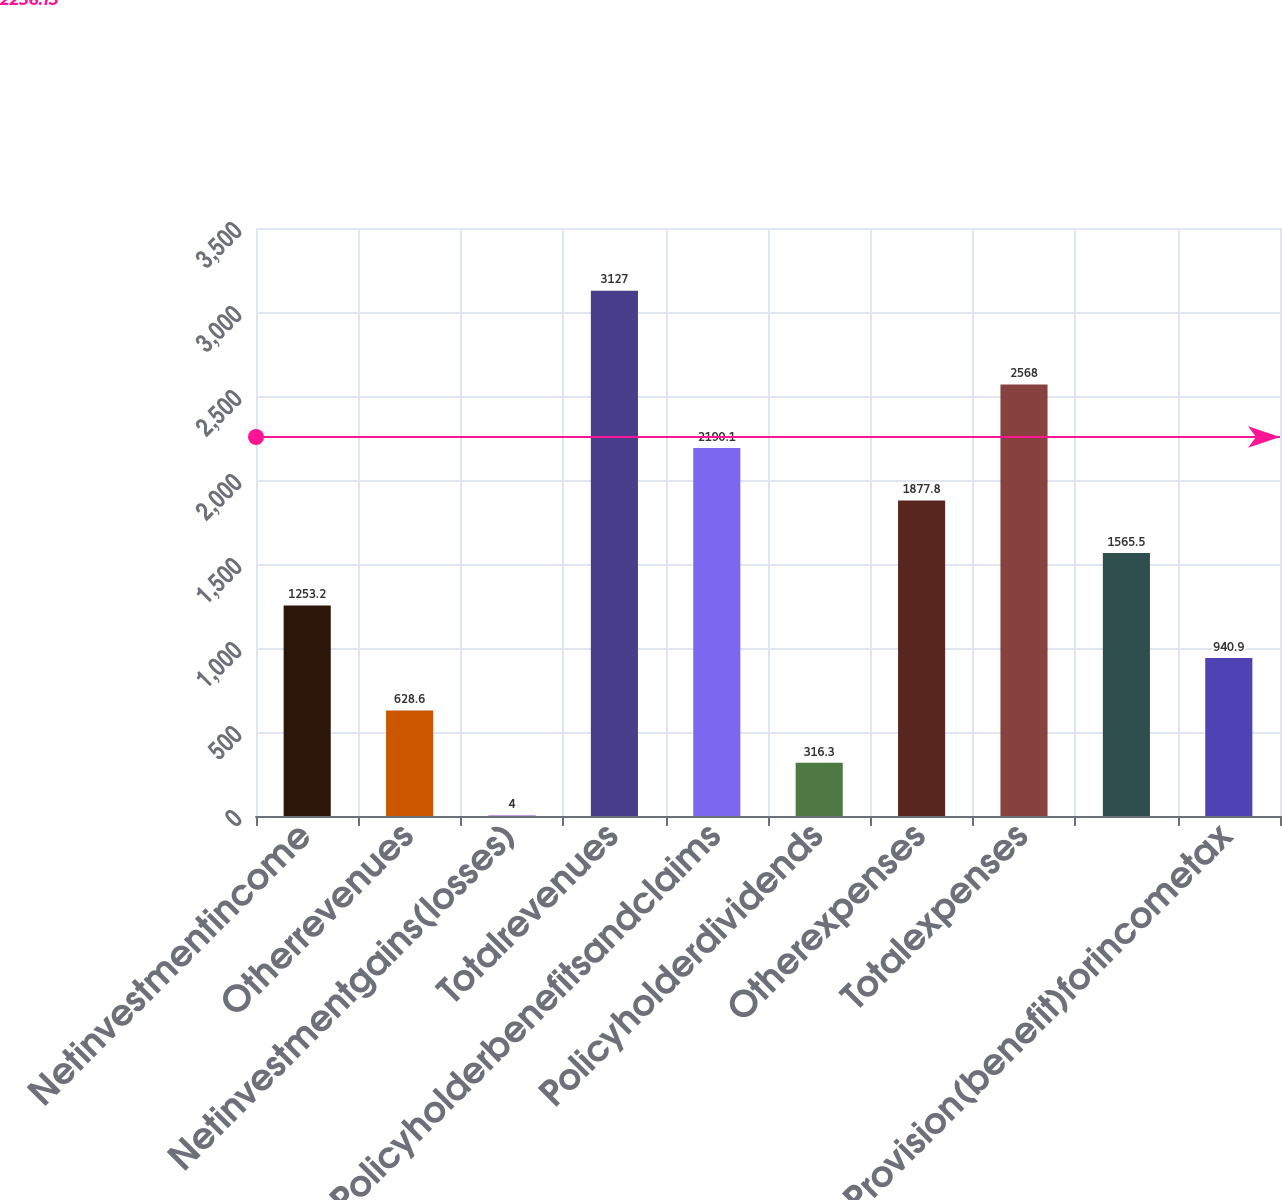<chart> <loc_0><loc_0><loc_500><loc_500><bar_chart><fcel>Netinvestmentincome<fcel>Otherrevenues<fcel>Netinvestmentgains(losses)<fcel>Totalrevenues<fcel>Policyholderbenefitsandclaims<fcel>Policyholderdividends<fcel>Otherexpenses<fcel>Totalexpenses<fcel>Unnamed: 8<fcel>Provision(benefit)forincometax<nl><fcel>1253.2<fcel>628.6<fcel>4<fcel>3127<fcel>2190.1<fcel>316.3<fcel>1877.8<fcel>2568<fcel>1565.5<fcel>940.9<nl></chart> 